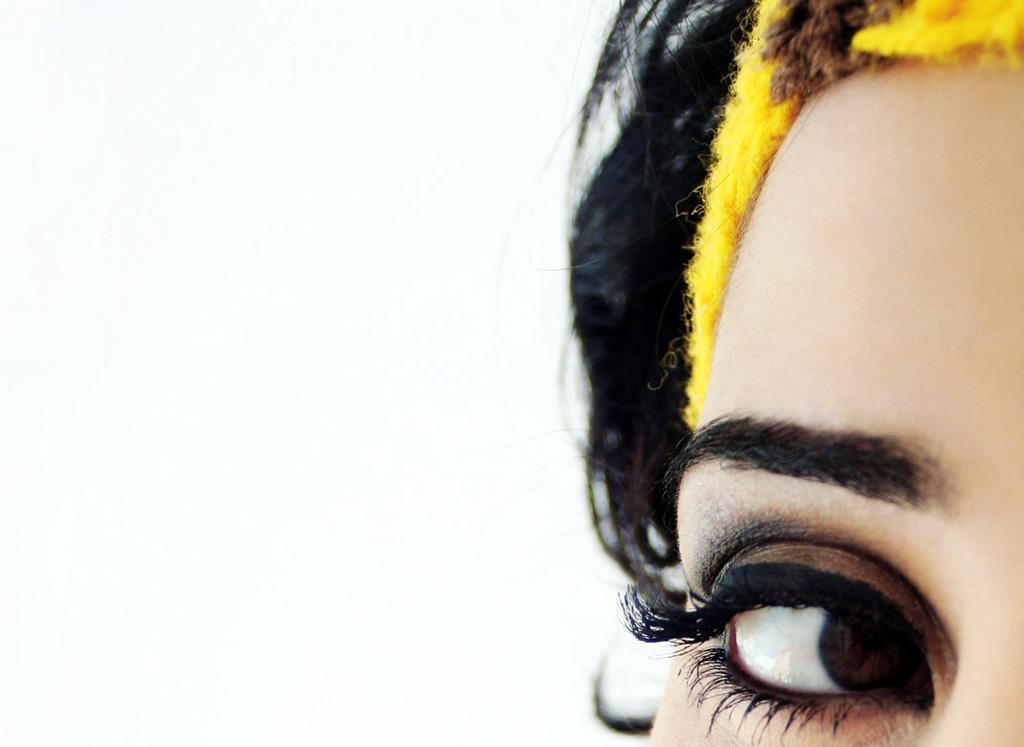What is the main subject of the image? The main subject of the image is a woman's eye. On which side of the image is the eye located? The eye is on the right side of the image. What is present above the eye in the image? There is an eyebrow above the eye in the image. What color is the background of the image? The background of the image is white. What type of leather ornament is hanging from the woman's eye in the image? There is no leather ornament present in the image; it only features a woman's eye and an eyebrow. 